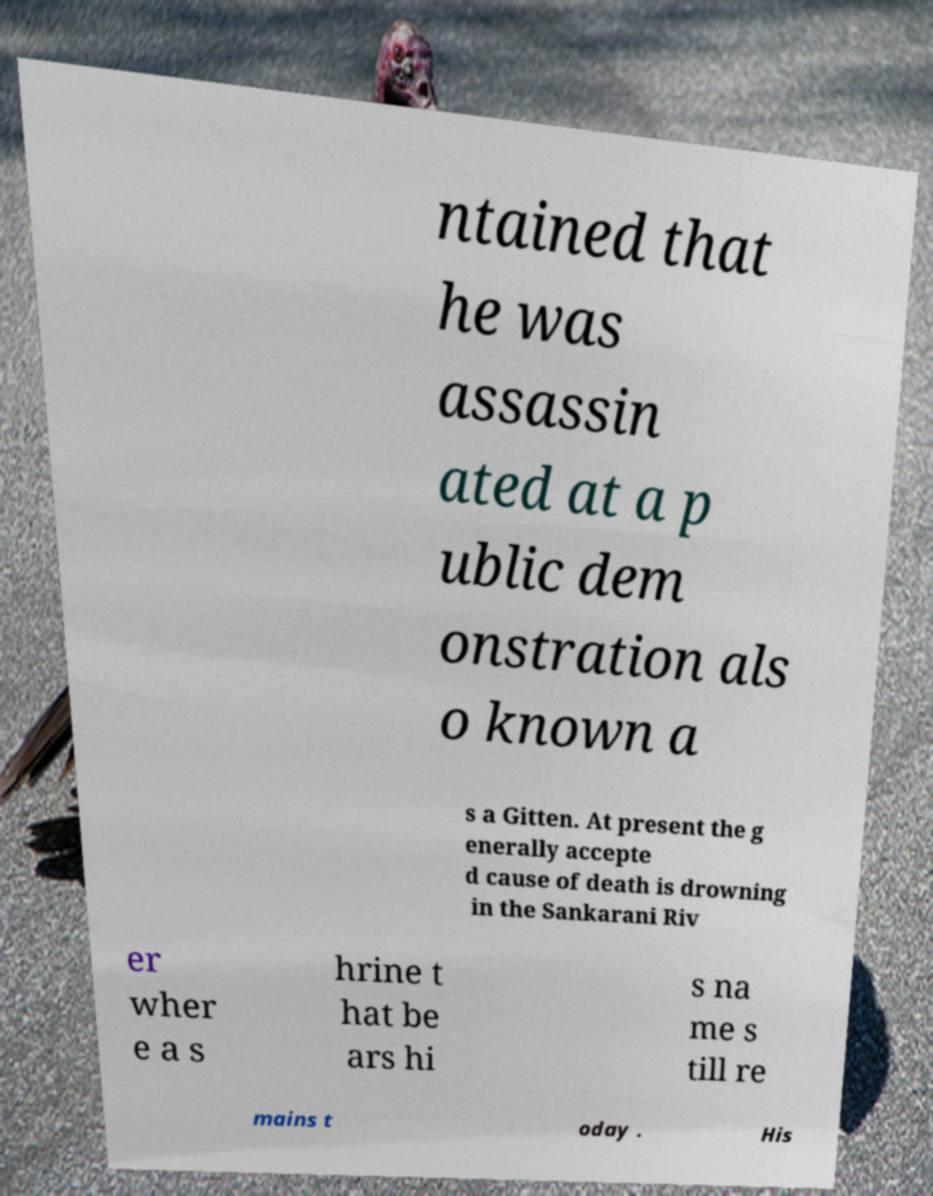There's text embedded in this image that I need extracted. Can you transcribe it verbatim? ntained that he was assassin ated at a p ublic dem onstration als o known a s a Gitten. At present the g enerally accepte d cause of death is drowning in the Sankarani Riv er wher e a s hrine t hat be ars hi s na me s till re mains t oday . His 